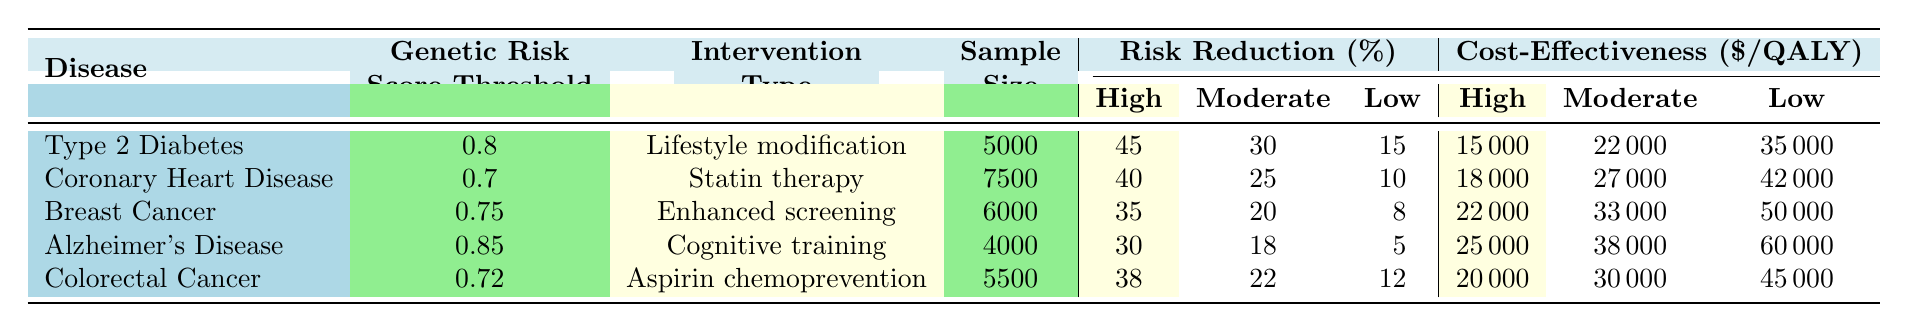What is the Genetic Risk Score Threshold for Type 2 Diabetes? The table lists the Genetic Risk Score Threshold for Type 2 Diabetes as 0.8.
Answer: 0.8 Which intervention type has the highest risk reduction percentage for High-Risk individuals? The table shows that Lifestyle modification for Type 2 Diabetes has the highest risk reduction percentage of 45% for High-Risk individuals.
Answer: Lifestyle modification What is the cost-effectiveness of Enhanced screening for Breast Cancer in Low-Risk individuals? The table indicates that the cost-effectiveness for Enhanced screening of Breast Cancer in Low-Risk individuals is $50,000.
Answer: $50,000 Calculate the average risk reduction percentage for Moderate-Risk individuals across all diseases. The risk reductions for Moderate-Risk individuals are 30, 25, 20, 18, and 22. The average is (30 + 25 + 20 + 18 + 22) / 5 = 23.
Answer: 23% Is the cost-effectiveness of Statin therapy for High-Risk individuals lower than that of Cognitive training for High-Risk individuals? The cost-effectiveness for Statin therapy for High-Risk individuals is $18,000, while for Cognitive training it is $25,000. Since $18,000 < $25,000, the statement is true.
Answer: Yes Which disease has the lowest risk reduction percentage for Low-Risk individuals, and what is that percentage? The disease with the lowest risk reduction percentage for Low-Risk individuals is Alzheimer's Disease, with a risk reduction of 5%.
Answer: Alzheimer's Disease, 5% What is the difference in cost-effectiveness between Aspirin chemoprevention for High-Risk and Low-Risk individuals? The cost-effectiveness for High-Risk individuals is $20,000, and for Low-Risk individuals, it is $45,000. The difference is $45,000 - $20,000 = $25,000.
Answer: $25,000 If you combine the sample sizes of Type 2 Diabetes and Colorectal Cancer, what is the total sample size? The sample size for Type 2 Diabetes is 5,000 and for Colorectal Cancer is 5,500. The total is 5,000 + 5,500 = 10,500.
Answer: 10,500 How does the risk reduction for Moderate-Risk individuals compare between Alzheimer's Disease and Coronary Heart Disease? Alzheimer's Disease has a risk reduction of 18% for Moderate-Risk individuals, while Coronary Heart Disease has 25%. Since 25% > 18%, Coronary Heart Disease has a higher risk reduction.
Answer: Coronary Heart Disease has a higher risk reduction What is the total sample size for all diseases listed in the table? The sample sizes for all diseases are 5,000 (Type 2 Diabetes) + 7,500 (Coronary Heart Disease) + 6,000 (Breast Cancer) + 4,000 (Alzheimer's Disease) + 5,500 (Colorectal Cancer). The total is 5,000 + 7,500 + 6,000 + 4,000 + 5,500 = 28,000.
Answer: 28,000 Is the risk reduction percentage for Low-Risk individuals in Type 2 Diabetes higher than that in Colorectal Cancer? Type 2 Diabetes has a risk reduction of 15% for Low-Risk individuals, while Colorectal Cancer has 12%. Since 15% > 12%, the statement is true.
Answer: Yes 